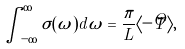<formula> <loc_0><loc_0><loc_500><loc_500>\int _ { - \infty } ^ { \infty } \sigma ( \omega ) d \omega = \frac { \pi } { L } \langle - \hat { T } \rangle ,</formula> 